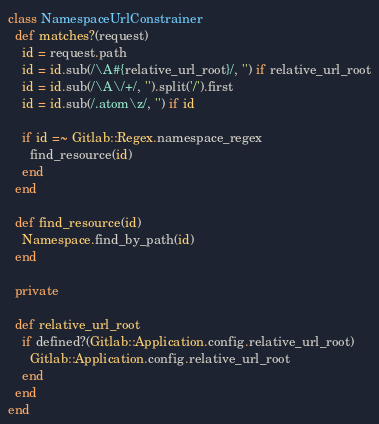Convert code to text. <code><loc_0><loc_0><loc_500><loc_500><_Ruby_>class NamespaceUrlConstrainer
  def matches?(request)
    id = request.path
    id = id.sub(/\A#{relative_url_root}/, '') if relative_url_root
    id = id.sub(/\A\/+/, '').split('/').first
    id = id.sub(/.atom\z/, '') if id

    if id =~ Gitlab::Regex.namespace_regex
      find_resource(id)
    end
  end

  def find_resource(id)
    Namespace.find_by_path(id)
  end

  private

  def relative_url_root
    if defined?(Gitlab::Application.config.relative_url_root)
      Gitlab::Application.config.relative_url_root
    end
  end
end
</code> 